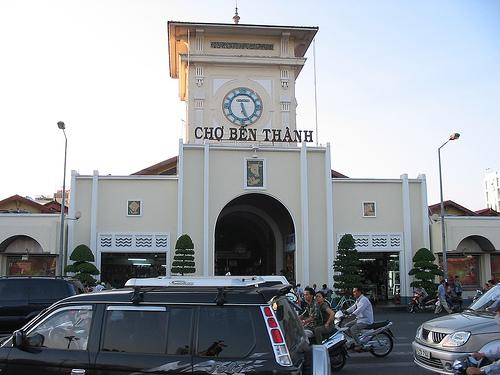Can you count how many bikers are in the image? There are two bikers in the image. What is the man wearing a blue shirt doing in the image? The man with a blue shirt and khaki pants is walking, carrying a white bag. In what type of shirt is the bike rider and what is his current action? The bike rider is wearing a white shirt and riding a motorbike. What type of trees are located by the entrance, and what is unusual about them? There are four green topiary trees by the entrance and they have an unusual trimming. Briefly describe the building in the image, including any unique features. The building is a large yellow and white Asian market place, with a white clock face, blue numbers, and an arched entrance. There are four green topiary trees outside the building. Identify the primary object located at the top of the building and its function. The primary object at the top of the building is a lightning rod, which functions to protect the building from lightning strikes. What is the color of the SUV in the foreground and what kind of roof rack does it have? The foreground SUV is black and has a silver hood rack. Are there any vehicles on the street besides the black SUV, and if so, what type are they? Yes, there is a silver gray vehicle and a silver SUV on the street. Describe the appearance of the clock on the front of the building. The clock has a white face, blue hands, and blue numbers located on a yellow building. What is the color of the light pole near the building and what is its position on the sidewalk? The light pole near the building is silver, and it's located near the sidewalk. 